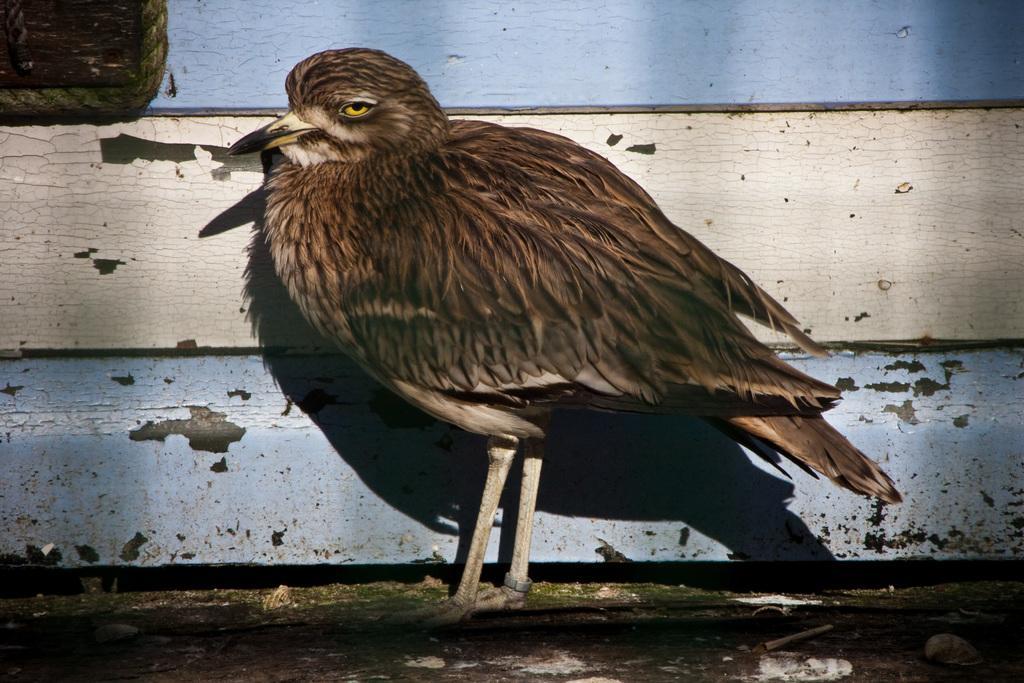Can you describe this image briefly? In this image I can see the bird which is in brown color. I can see the blue and cream color background. 